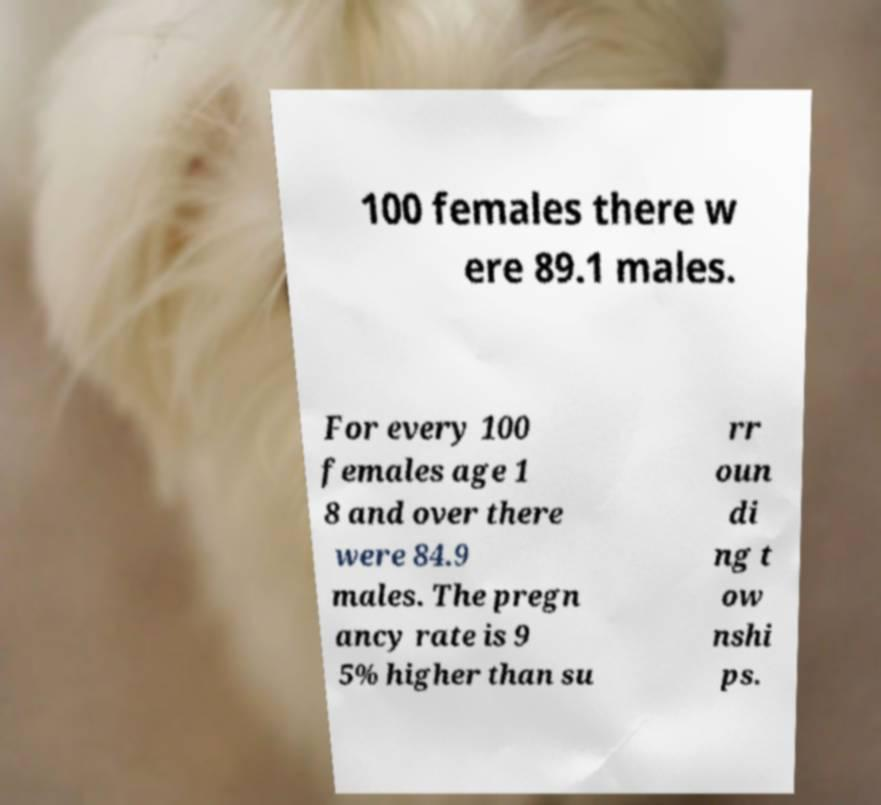For documentation purposes, I need the text within this image transcribed. Could you provide that? 100 females there w ere 89.1 males. For every 100 females age 1 8 and over there were 84.9 males. The pregn ancy rate is 9 5% higher than su rr oun di ng t ow nshi ps. 